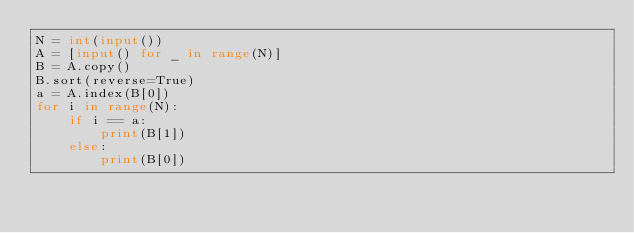<code> <loc_0><loc_0><loc_500><loc_500><_Python_>N = int(input())
A = [input() for _ in range(N)]
B = A.copy()
B.sort(reverse=True)
a = A.index(B[0])
for i in range(N):
    if i == a:
        print(B[1])
    else:
        print(B[0])</code> 